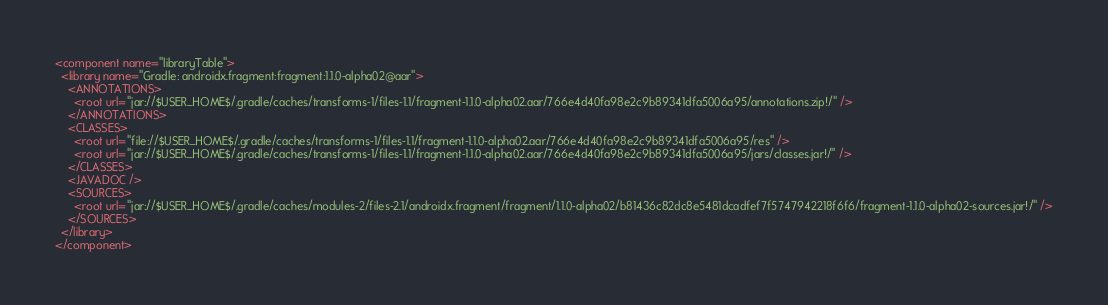<code> <loc_0><loc_0><loc_500><loc_500><_XML_><component name="libraryTable">
  <library name="Gradle: androidx.fragment:fragment:1.1.0-alpha02@aar">
    <ANNOTATIONS>
      <root url="jar://$USER_HOME$/.gradle/caches/transforms-1/files-1.1/fragment-1.1.0-alpha02.aar/766e4d40fa98e2c9b89341dfa5006a95/annotations.zip!/" />
    </ANNOTATIONS>
    <CLASSES>
      <root url="file://$USER_HOME$/.gradle/caches/transforms-1/files-1.1/fragment-1.1.0-alpha02.aar/766e4d40fa98e2c9b89341dfa5006a95/res" />
      <root url="jar://$USER_HOME$/.gradle/caches/transforms-1/files-1.1/fragment-1.1.0-alpha02.aar/766e4d40fa98e2c9b89341dfa5006a95/jars/classes.jar!/" />
    </CLASSES>
    <JAVADOC />
    <SOURCES>
      <root url="jar://$USER_HOME$/.gradle/caches/modules-2/files-2.1/androidx.fragment/fragment/1.1.0-alpha02/b81436c82dc8e5481dcadfef7f5747942218f6f6/fragment-1.1.0-alpha02-sources.jar!/" />
    </SOURCES>
  </library>
</component></code> 